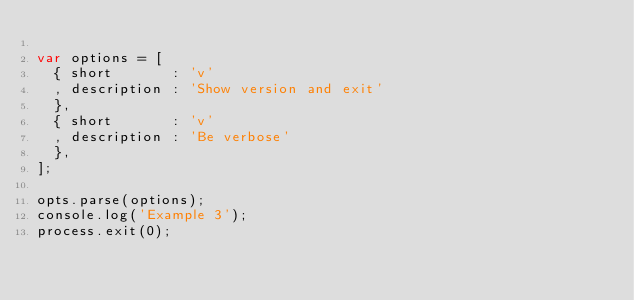Convert code to text. <code><loc_0><loc_0><loc_500><loc_500><_JavaScript_>
var options = [
  { short       : 'v'
  , description : 'Show version and exit'
  },
  { short       : 'v'
  , description : 'Be verbose'
  },
];

opts.parse(options);
console.log('Example 3');
process.exit(0);


</code> 